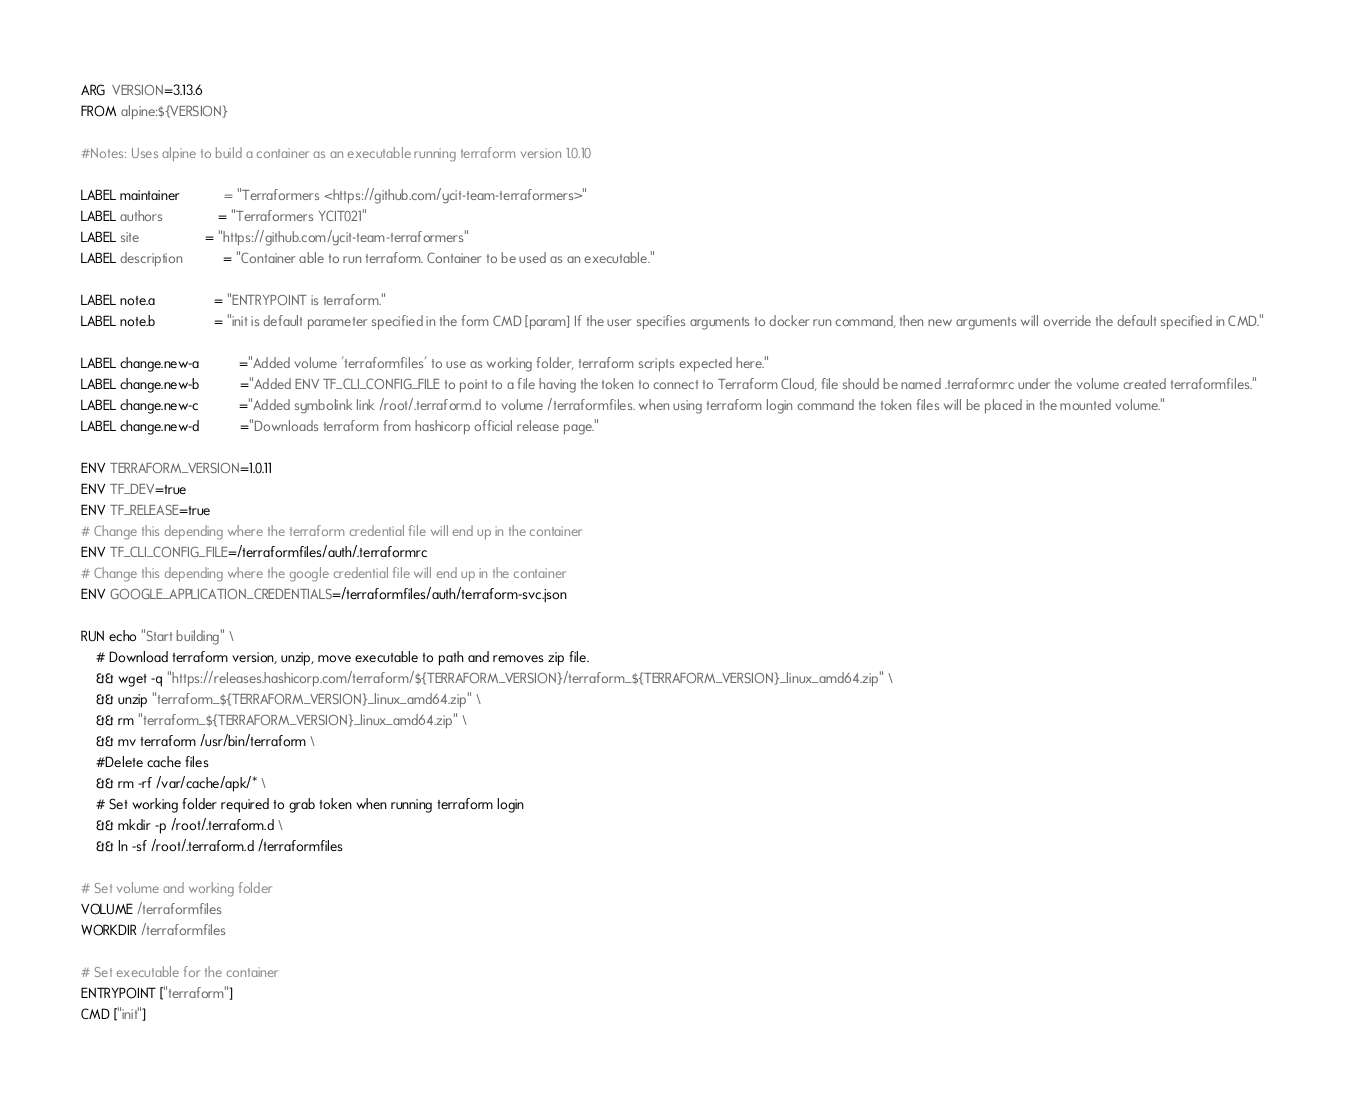<code> <loc_0><loc_0><loc_500><loc_500><_Dockerfile_>ARG  VERSION=3.13.6
FROM alpine:${VERSION}

#Notes: Uses alpine to build a container as an executable running terraform version 1.0.10

LABEL maintainer            = "Terraformers <https://github.com/ycit-team-terraformers>"
LABEL authors               = "Terraformers YCIT021"
LABEL site                  = "https://github.com/ycit-team-terraformers"
LABEL description           = "Container able to run terraform. Container to be used as an executable."

LABEL note.a                = "ENTRYPOINT is terraform."
LABEL note.b                = "init is default parameter specified in the form CMD [param] If the user specifies arguments to docker run command, then new arguments will override the default specified in CMD."

LABEL change.new-a           ="Added volume 'terraformfiles' to use as working folder, terraform scripts expected here."
LABEL change.new-b           ="Added ENV TF_CLI_CONFIG_FILE to point to a file having the token to connect to Terraform Cloud, file should be named .terraformrc under the volume created terraformfiles."
LABEL change.new-c           ="Added symbolink link /root/.terraform.d to volume /terraformfiles. when using terraform login command the token files will be placed in the mounted volume."
LABEL change.new-d           ="Downloads terraform from hashicorp official release page."

ENV TERRAFORM_VERSION=1.0.11
ENV TF_DEV=true
ENV TF_RELEASE=true
# Change this depending where the terraform credential file will end up in the container
ENV TF_CLI_CONFIG_FILE=/terraformfiles/auth/.terraformrc
# Change this depending where the google credential file will end up in the container
ENV GOOGLE_APPLICATION_CREDENTIALS=/terraformfiles/auth/terraform-svc.json

RUN echo "Start building" \
    # Download terraform version, unzip, move executable to path and removes zip file.
    && wget -q "https://releases.hashicorp.com/terraform/${TERRAFORM_VERSION}/terraform_${TERRAFORM_VERSION}_linux_amd64.zip" \
    && unzip "terraform_${TERRAFORM_VERSION}_linux_amd64.zip" \
    && rm "terraform_${TERRAFORM_VERSION}_linux_amd64.zip" \
    && mv terraform /usr/bin/terraform \
    #Delete cache files
    && rm -rf /var/cache/apk/* \
    # Set working folder required to grab token when running terraform login 
    && mkdir -p /root/.terraform.d \
    && ln -sf /root/.terraform.d /terraformfiles

# Set volume and working folder
VOLUME /terraformfiles
WORKDIR /terraformfiles

# Set executable for the container
ENTRYPOINT ["terraform"]
CMD ["init"]</code> 